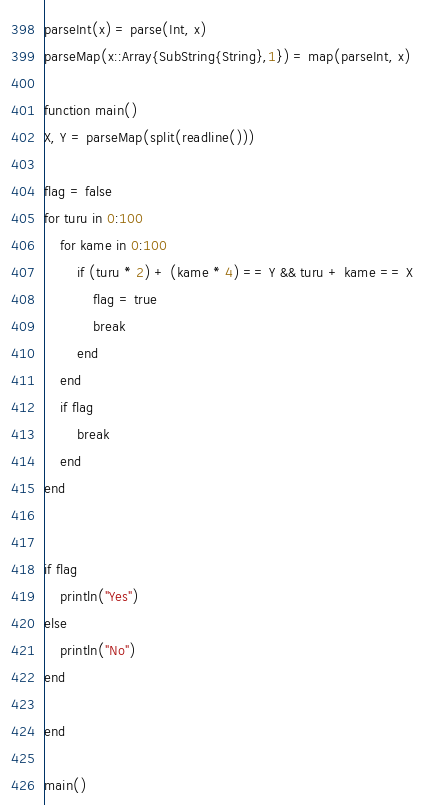<code> <loc_0><loc_0><loc_500><loc_500><_Julia_>parseInt(x) = parse(Int, x)
parseMap(x::Array{SubString{String},1}) = map(parseInt, x)

function main()
X, Y = parseMap(split(readline()))

flag = false
for turu in 0:100
    for kame in 0:100
        if (turu * 2) + (kame * 4) == Y && turu + kame == X
            flag = true
            break
        end
    end
    if flag
        break
    end
end


if flag
    println("Yes")
else
    println("No")
end

end

main()</code> 